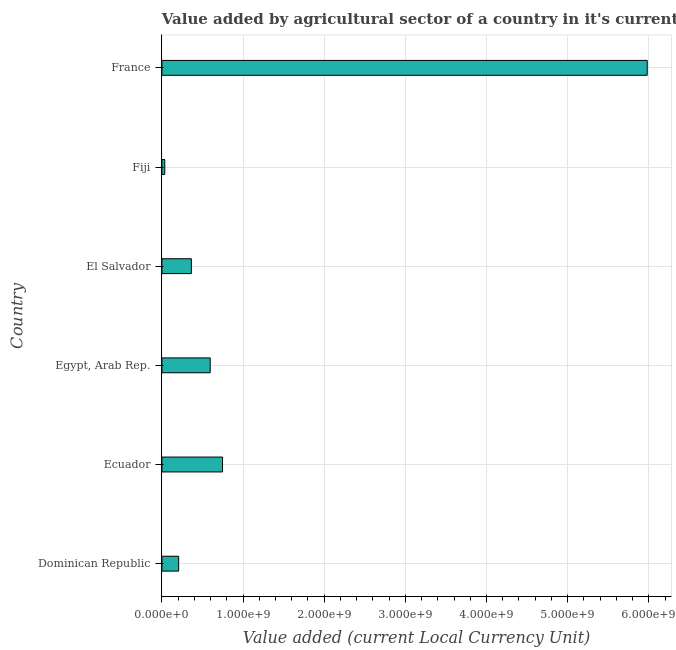Does the graph contain any zero values?
Give a very brief answer. No. Does the graph contain grids?
Offer a terse response. Yes. What is the title of the graph?
Offer a terse response. Value added by agricultural sector of a country in it's current local currency unit. What is the label or title of the X-axis?
Your response must be concise. Value added (current Local Currency Unit). What is the value added by agriculture sector in El Salvador?
Ensure brevity in your answer.  3.63e+08. Across all countries, what is the maximum value added by agriculture sector?
Your answer should be very brief. 5.98e+09. Across all countries, what is the minimum value added by agriculture sector?
Your response must be concise. 3.54e+07. In which country was the value added by agriculture sector minimum?
Give a very brief answer. Fiji. What is the sum of the value added by agriculture sector?
Ensure brevity in your answer.  7.93e+09. What is the difference between the value added by agriculture sector in El Salvador and France?
Provide a succinct answer. -5.62e+09. What is the average value added by agriculture sector per country?
Your response must be concise. 1.32e+09. What is the median value added by agriculture sector?
Your answer should be compact. 4.79e+08. In how many countries, is the value added by agriculture sector greater than 400000000 LCU?
Your answer should be very brief. 3. What is the ratio of the value added by agriculture sector in Dominican Republic to that in Ecuador?
Your answer should be compact. 0.28. What is the difference between the highest and the second highest value added by agriculture sector?
Your answer should be compact. 5.23e+09. What is the difference between the highest and the lowest value added by agriculture sector?
Your response must be concise. 5.95e+09. In how many countries, is the value added by agriculture sector greater than the average value added by agriculture sector taken over all countries?
Your answer should be compact. 1. How many bars are there?
Give a very brief answer. 6. Are all the bars in the graph horizontal?
Keep it short and to the point. Yes. How many countries are there in the graph?
Provide a short and direct response. 6. What is the Value added (current Local Currency Unit) of Dominican Republic?
Your answer should be compact. 2.06e+08. What is the Value added (current Local Currency Unit) of Ecuador?
Give a very brief answer. 7.47e+08. What is the Value added (current Local Currency Unit) of Egypt, Arab Rep.?
Your response must be concise. 5.95e+08. What is the Value added (current Local Currency Unit) of El Salvador?
Offer a very short reply. 3.63e+08. What is the Value added (current Local Currency Unit) of Fiji?
Ensure brevity in your answer.  3.54e+07. What is the Value added (current Local Currency Unit) of France?
Offer a terse response. 5.98e+09. What is the difference between the Value added (current Local Currency Unit) in Dominican Republic and Ecuador?
Offer a terse response. -5.41e+08. What is the difference between the Value added (current Local Currency Unit) in Dominican Republic and Egypt, Arab Rep.?
Offer a terse response. -3.89e+08. What is the difference between the Value added (current Local Currency Unit) in Dominican Republic and El Salvador?
Your answer should be compact. -1.57e+08. What is the difference between the Value added (current Local Currency Unit) in Dominican Republic and Fiji?
Your answer should be very brief. 1.71e+08. What is the difference between the Value added (current Local Currency Unit) in Dominican Republic and France?
Provide a succinct answer. -5.77e+09. What is the difference between the Value added (current Local Currency Unit) in Ecuador and Egypt, Arab Rep.?
Offer a very short reply. 1.52e+08. What is the difference between the Value added (current Local Currency Unit) in Ecuador and El Salvador?
Your answer should be very brief. 3.84e+08. What is the difference between the Value added (current Local Currency Unit) in Ecuador and Fiji?
Your answer should be compact. 7.12e+08. What is the difference between the Value added (current Local Currency Unit) in Ecuador and France?
Give a very brief answer. -5.23e+09. What is the difference between the Value added (current Local Currency Unit) in Egypt, Arab Rep. and El Salvador?
Keep it short and to the point. 2.32e+08. What is the difference between the Value added (current Local Currency Unit) in Egypt, Arab Rep. and Fiji?
Provide a short and direct response. 5.60e+08. What is the difference between the Value added (current Local Currency Unit) in Egypt, Arab Rep. and France?
Offer a terse response. -5.39e+09. What is the difference between the Value added (current Local Currency Unit) in El Salvador and Fiji?
Keep it short and to the point. 3.28e+08. What is the difference between the Value added (current Local Currency Unit) in El Salvador and France?
Make the answer very short. -5.62e+09. What is the difference between the Value added (current Local Currency Unit) in Fiji and France?
Your response must be concise. -5.95e+09. What is the ratio of the Value added (current Local Currency Unit) in Dominican Republic to that in Ecuador?
Provide a short and direct response. 0.28. What is the ratio of the Value added (current Local Currency Unit) in Dominican Republic to that in Egypt, Arab Rep.?
Your response must be concise. 0.35. What is the ratio of the Value added (current Local Currency Unit) in Dominican Republic to that in El Salvador?
Ensure brevity in your answer.  0.57. What is the ratio of the Value added (current Local Currency Unit) in Dominican Republic to that in Fiji?
Ensure brevity in your answer.  5.83. What is the ratio of the Value added (current Local Currency Unit) in Dominican Republic to that in France?
Provide a short and direct response. 0.04. What is the ratio of the Value added (current Local Currency Unit) in Ecuador to that in Egypt, Arab Rep.?
Your answer should be very brief. 1.25. What is the ratio of the Value added (current Local Currency Unit) in Ecuador to that in El Salvador?
Ensure brevity in your answer.  2.06. What is the ratio of the Value added (current Local Currency Unit) in Ecuador to that in Fiji?
Your response must be concise. 21.11. What is the ratio of the Value added (current Local Currency Unit) in Ecuador to that in France?
Offer a terse response. 0.12. What is the ratio of the Value added (current Local Currency Unit) in Egypt, Arab Rep. to that in El Salvador?
Offer a terse response. 1.64. What is the ratio of the Value added (current Local Currency Unit) in Egypt, Arab Rep. to that in Fiji?
Make the answer very short. 16.82. What is the ratio of the Value added (current Local Currency Unit) in Egypt, Arab Rep. to that in France?
Provide a short and direct response. 0.1. What is the ratio of the Value added (current Local Currency Unit) in El Salvador to that in Fiji?
Make the answer very short. 10.26. What is the ratio of the Value added (current Local Currency Unit) in El Salvador to that in France?
Keep it short and to the point. 0.06. What is the ratio of the Value added (current Local Currency Unit) in Fiji to that in France?
Make the answer very short. 0.01. 